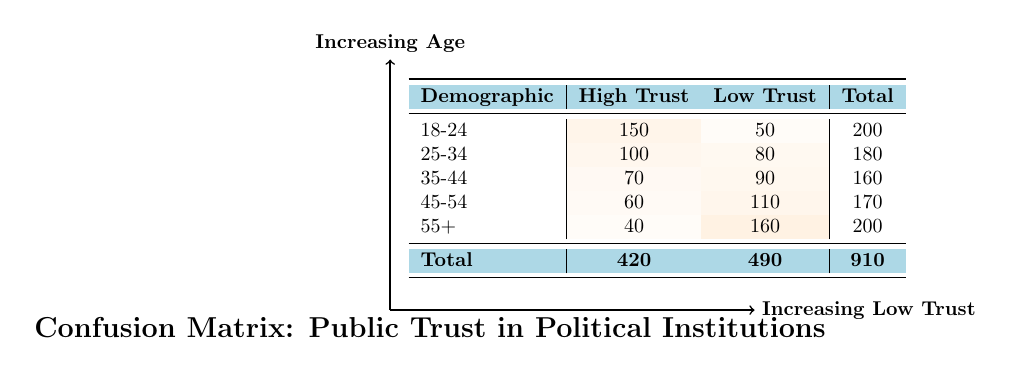What is the total number of respondents from the demographic 25-34? To find the total number of respondents from the demographic 25-34, we look at the "Total" column for this row, which is listed as 180.
Answer: 180 What is the count of respondents with high trust in the 55+ demographic? The table shows that the count of respondents with high trust in the 55+ demographic is listed as 40.
Answer: 40 Is it true that more respondents aged 45-54 have low trust than those aged 35-44? Checking the counts, 110 respondents aged 45-54 have low trust, while 90 respondents aged 35-44 have low trust. Since 110 is greater than 90, the statement is true.
Answer: Yes What is the total number of respondents across all age demographics who have high political trust? To find this, we sum the "High Trust" counts: 150 + 100 + 70 + 60 + 40 = 420. The total number of respondents who have high political trust is 420.
Answer: 420 What percentage of respondents aged 18-24 reported having low political trust? The total for the 18-24 demographic is 200. The count for low trust is 50. To find the percentage: (50 / 200) * 100 = 25%. Thus, 25% of respondents aged 18-24 reported having low political trust.
Answer: 25% For the demographic 45-54, how much higher is the count of low trust respondents compared to high trust respondents? The count for low trust in the 45-54 demographic is 110, and for high trust, it is 60. The difference is 110 - 60 = 50. Therefore, the count of low trust respondents is 50 higher than that of high trust respondents.
Answer: 50 What is the overall trust level (high vs. low) across all demographics? To summarize the levels of trust, we see the overall counts: High Trust = 420 and Low Trust = 490. This indicates that there are more respondents with low trust overall when comparing these totals.
Answer: More low trust Which demographic has the highest count of respondents who reported high trust? Looking at the "High Trust" counts, the age group 18-24 has the highest with 150 respondents.
Answer: 18-24 How many more people have low political trust in the 55+ demographic compared to the 25-34 demographic? The count for low trust in the 55+ demographic is 160 and in the 25-34 demographic it is 80. The difference is 160 - 80 = 80. Therefore, 80 more people have low political trust in the 55+ demographic compared to the 25-34 demographic.
Answer: 80 